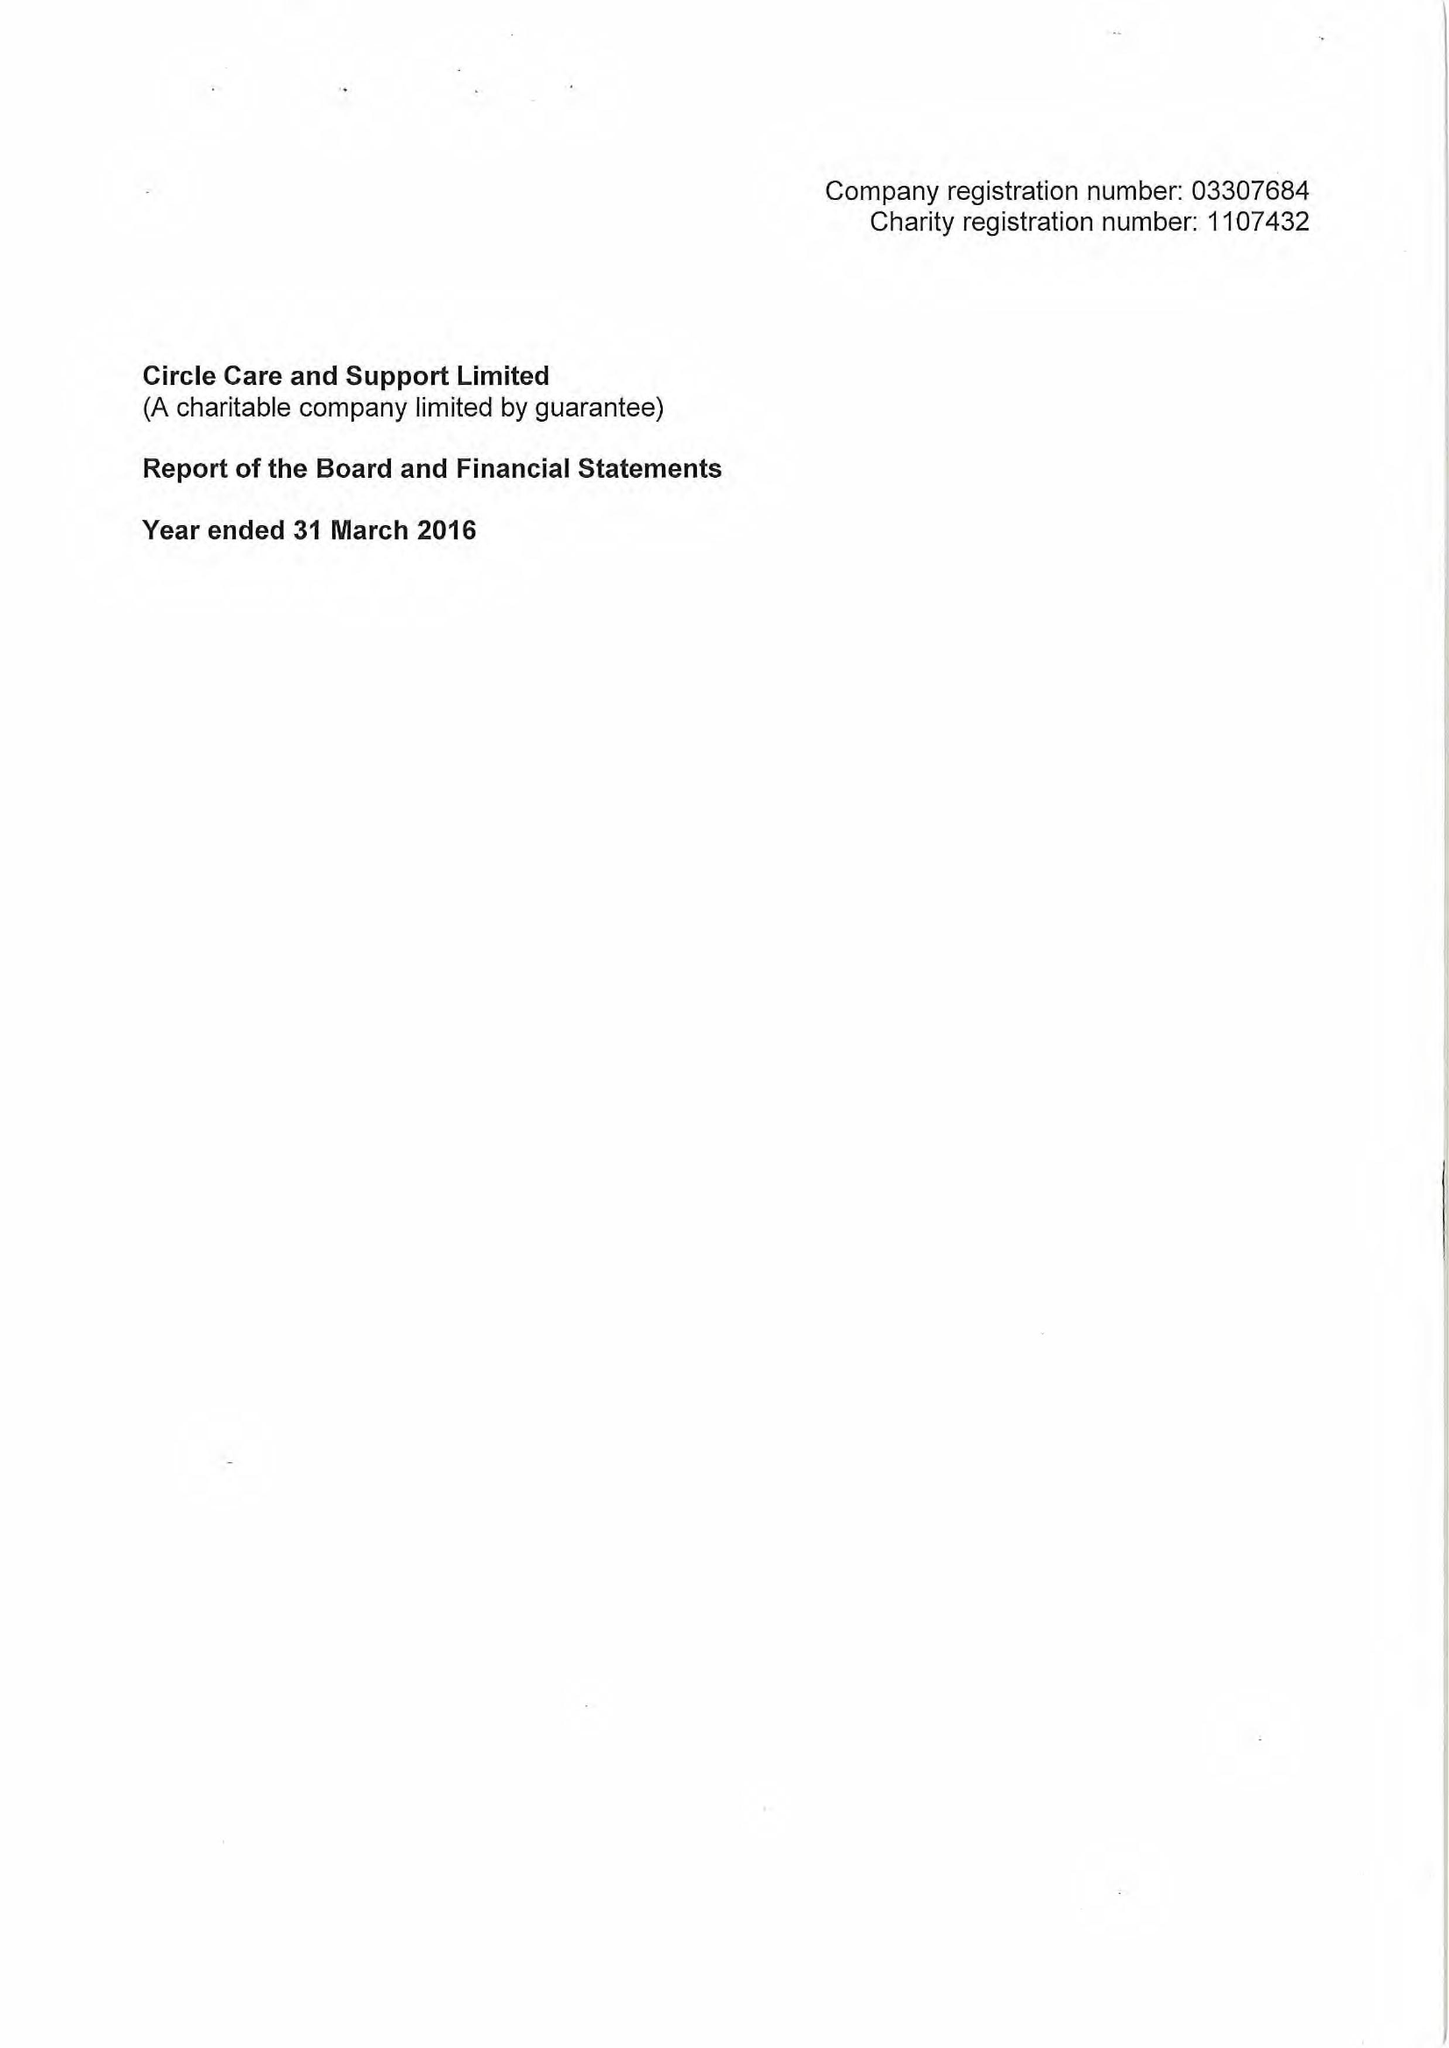What is the value for the address__postcode?
Answer the question using a single word or phrase. SE1 2DA 